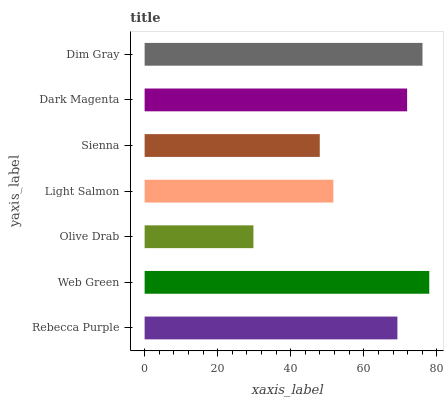Is Olive Drab the minimum?
Answer yes or no. Yes. Is Web Green the maximum?
Answer yes or no. Yes. Is Web Green the minimum?
Answer yes or no. No. Is Olive Drab the maximum?
Answer yes or no. No. Is Web Green greater than Olive Drab?
Answer yes or no. Yes. Is Olive Drab less than Web Green?
Answer yes or no. Yes. Is Olive Drab greater than Web Green?
Answer yes or no. No. Is Web Green less than Olive Drab?
Answer yes or no. No. Is Rebecca Purple the high median?
Answer yes or no. Yes. Is Rebecca Purple the low median?
Answer yes or no. Yes. Is Light Salmon the high median?
Answer yes or no. No. Is Dim Gray the low median?
Answer yes or no. No. 